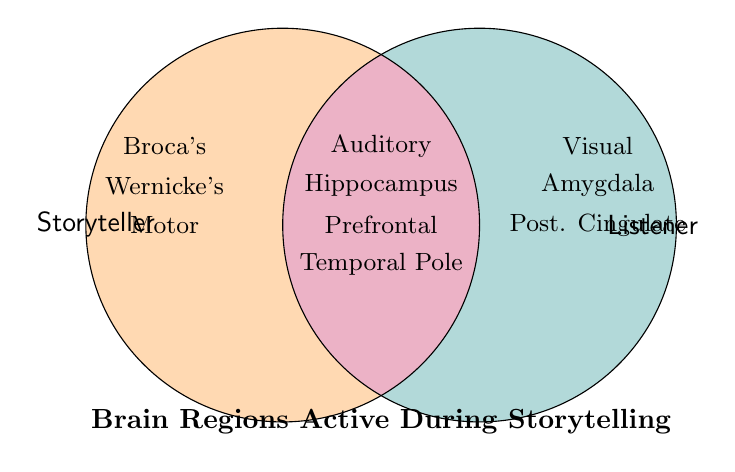Is Broca's Area active for Storyteller or Listener? Broca's Area is placed in the circle representing the Storyteller.
Answer: Storyteller Which brain region is active for both Storyteller and Listener? The overlapping part of the two circles, representing both Storyteller and Listener, contains Auditory Cortex, Hippocampus, Prefrontal Cortex, and Temporal Pole. Any one of these answers is correct.
Answer: Auditory Cortex (or Hippocampus / Prefrontal Cortex / Temporal Pole) What brain regions are only active in the Listener? Brain regions that are only in the Listener's circle without overlapping with the Storyteller's circle are Visual Cortex, Amygdala, and Posterior Cingulate.
Answer: Visual Cortex, Amygdala, Posterior Cingulate How many brain regions are active in both Storyteller and Listener? The overlapping segment of the two circles includes Auditory Cortex, Hippocampus, Prefrontal Cortex, and Temporal Pole, which are 4 regions in total.
Answer: 4 Is the Motor Cortex active during storytelling for the Listener? The Motor Cortex is located in the section that represents the Storyteller but not the Listener, therefore it is not active for the Listener.
Answer: No Which brain region is active for the Storyteller but not the Listener, placed in close proximity to Broca's Area and Wernicke's Area? Motor Cortex is placed in the Storyteller's circle near Broca's Area and Wernicke's Area.
Answer: Motor Cortex Which brain regions are active only when someone is listening to a story? The brain regions exclusively in the Listener's circle are Visual Cortex, Amygdala, and Posterior Cingulate.
Answer: Visual Cortex, Amygdala, Posterior Cingulate Do Storyteller and Listener share activation in Wernicke's Area? Wernicke's Area is located in the Storyteller's circle and does not overlap with the Listener's, indicating it is only active for the Storyteller.
Answer: No Which brain region associated with emotions is only active in the Listener? Amygdala, related to emotions, is placed in the Listener's circle.
Answer: Amygdala Name two brain regions that are part of the overlapping segment where both circles intersect. From the overlapping section, two brain regions are Auditory Cortex and Hippocampus; any two of these regions are correct answers.
Answer: Auditory Cortex, Hippocampus 